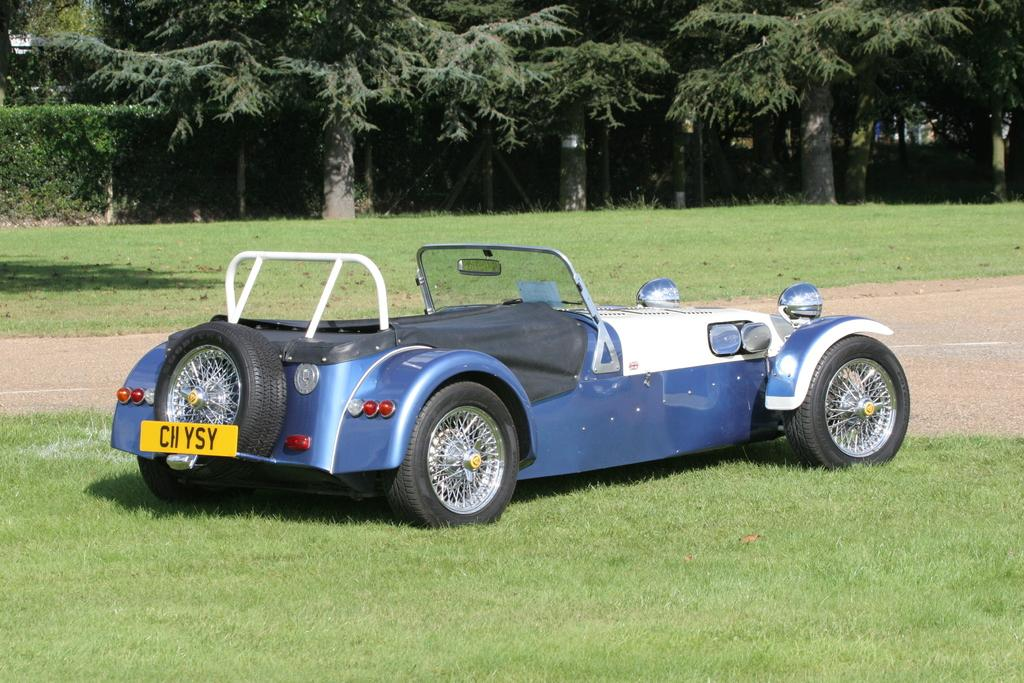What is the main subject in the foreground of the image? There is a vehicle in the foreground of the image. What can be seen in the background of the image? There are trees visible in the background of the image. What type of ground is present at the bottom of the image? There is grass at the bottom of the image. What is the purpose of the road in the image? The road in the image is likely for vehicles to travel on. What type of jewel can be seen on the page in the image? There is no jewel or page present in the image; it features a vehicle, trees, grass, and a road. 